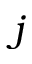Convert formula to latex. <formula><loc_0><loc_0><loc_500><loc_500>j</formula> 